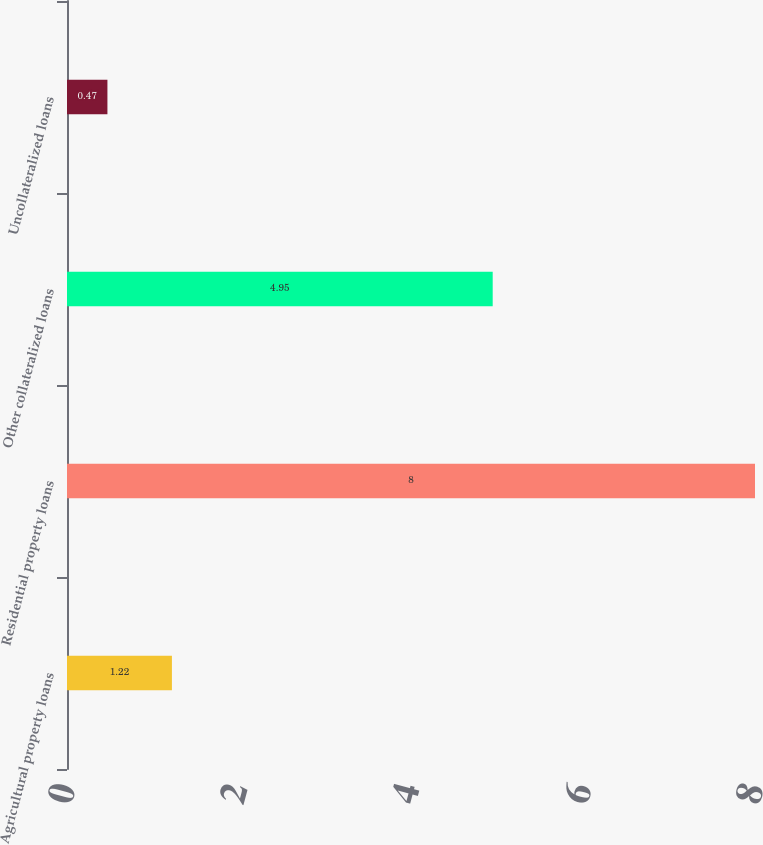<chart> <loc_0><loc_0><loc_500><loc_500><bar_chart><fcel>Agricultural property loans<fcel>Residential property loans<fcel>Other collateralized loans<fcel>Uncollateralized loans<nl><fcel>1.22<fcel>8<fcel>4.95<fcel>0.47<nl></chart> 